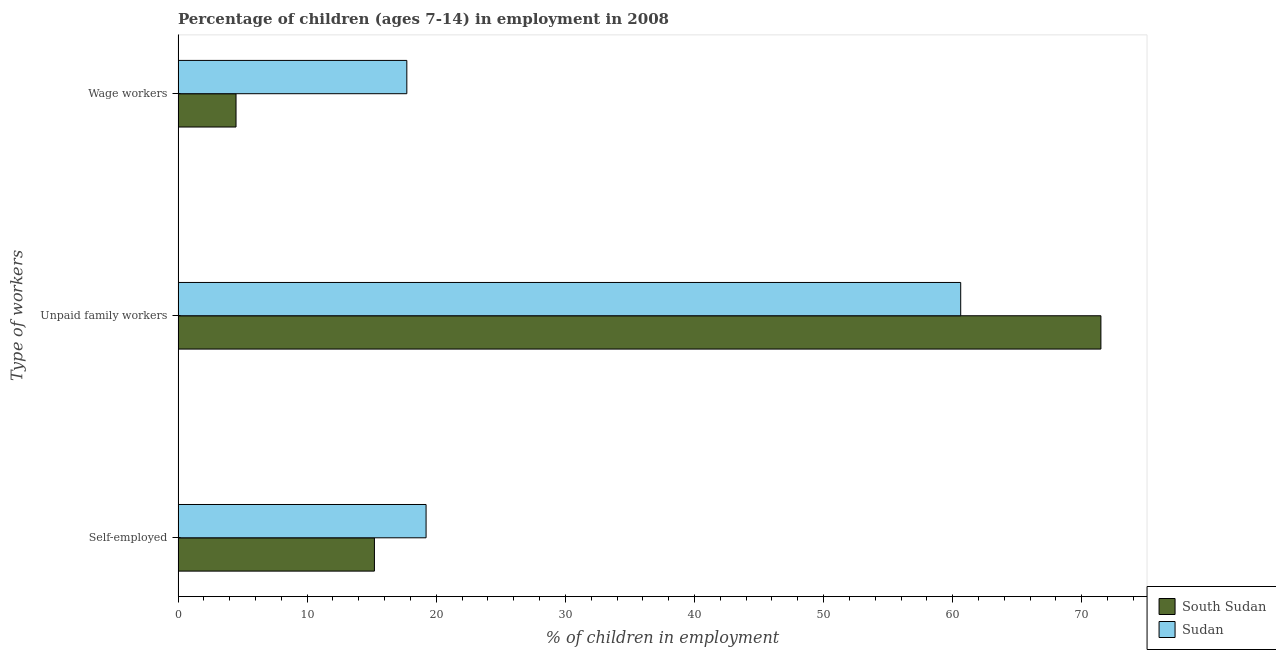How many groups of bars are there?
Keep it short and to the point. 3. Are the number of bars per tick equal to the number of legend labels?
Ensure brevity in your answer.  Yes. How many bars are there on the 3rd tick from the top?
Give a very brief answer. 2. What is the label of the 3rd group of bars from the top?
Your answer should be compact. Self-employed. What is the percentage of self employed children in Sudan?
Your response must be concise. 19.21. Across all countries, what is the maximum percentage of children employed as wage workers?
Ensure brevity in your answer.  17.72. Across all countries, what is the minimum percentage of children employed as wage workers?
Your answer should be very brief. 4.49. In which country was the percentage of children employed as unpaid family workers maximum?
Make the answer very short. South Sudan. In which country was the percentage of children employed as wage workers minimum?
Make the answer very short. South Sudan. What is the total percentage of children employed as wage workers in the graph?
Provide a succinct answer. 22.21. What is the difference between the percentage of children employed as unpaid family workers in South Sudan and that in Sudan?
Make the answer very short. 10.86. What is the difference between the percentage of children employed as unpaid family workers in South Sudan and the percentage of self employed children in Sudan?
Keep it short and to the point. 52.27. What is the average percentage of children employed as unpaid family workers per country?
Provide a short and direct response. 66.05. What is the difference between the percentage of children employed as wage workers and percentage of children employed as unpaid family workers in South Sudan?
Your response must be concise. -66.99. What is the ratio of the percentage of self employed children in South Sudan to that in Sudan?
Make the answer very short. 0.79. Is the percentage of children employed as wage workers in Sudan less than that in South Sudan?
Make the answer very short. No. Is the difference between the percentage of self employed children in South Sudan and Sudan greater than the difference between the percentage of children employed as unpaid family workers in South Sudan and Sudan?
Give a very brief answer. No. What is the difference between the highest and the second highest percentage of children employed as wage workers?
Ensure brevity in your answer.  13.23. In how many countries, is the percentage of children employed as unpaid family workers greater than the average percentage of children employed as unpaid family workers taken over all countries?
Your answer should be very brief. 1. What does the 2nd bar from the top in Self-employed represents?
Give a very brief answer. South Sudan. What does the 2nd bar from the bottom in Self-employed represents?
Give a very brief answer. Sudan. What is the difference between two consecutive major ticks on the X-axis?
Offer a terse response. 10. Are the values on the major ticks of X-axis written in scientific E-notation?
Provide a short and direct response. No. Where does the legend appear in the graph?
Ensure brevity in your answer.  Bottom right. How many legend labels are there?
Provide a short and direct response. 2. How are the legend labels stacked?
Your response must be concise. Vertical. What is the title of the graph?
Make the answer very short. Percentage of children (ages 7-14) in employment in 2008. Does "Switzerland" appear as one of the legend labels in the graph?
Your answer should be very brief. No. What is the label or title of the X-axis?
Give a very brief answer. % of children in employment. What is the label or title of the Y-axis?
Your response must be concise. Type of workers. What is the % of children in employment in South Sudan in Self-employed?
Your answer should be compact. 15.21. What is the % of children in employment in Sudan in Self-employed?
Offer a very short reply. 19.21. What is the % of children in employment in South Sudan in Unpaid family workers?
Make the answer very short. 71.48. What is the % of children in employment of Sudan in Unpaid family workers?
Keep it short and to the point. 60.62. What is the % of children in employment of South Sudan in Wage workers?
Offer a terse response. 4.49. What is the % of children in employment in Sudan in Wage workers?
Give a very brief answer. 17.72. Across all Type of workers, what is the maximum % of children in employment in South Sudan?
Provide a short and direct response. 71.48. Across all Type of workers, what is the maximum % of children in employment in Sudan?
Ensure brevity in your answer.  60.62. Across all Type of workers, what is the minimum % of children in employment of South Sudan?
Your answer should be very brief. 4.49. Across all Type of workers, what is the minimum % of children in employment in Sudan?
Keep it short and to the point. 17.72. What is the total % of children in employment of South Sudan in the graph?
Provide a short and direct response. 91.18. What is the total % of children in employment in Sudan in the graph?
Make the answer very short. 97.55. What is the difference between the % of children in employment in South Sudan in Self-employed and that in Unpaid family workers?
Offer a very short reply. -56.27. What is the difference between the % of children in employment of Sudan in Self-employed and that in Unpaid family workers?
Provide a succinct answer. -41.41. What is the difference between the % of children in employment of South Sudan in Self-employed and that in Wage workers?
Offer a terse response. 10.72. What is the difference between the % of children in employment in Sudan in Self-employed and that in Wage workers?
Your answer should be very brief. 1.49. What is the difference between the % of children in employment in South Sudan in Unpaid family workers and that in Wage workers?
Make the answer very short. 66.99. What is the difference between the % of children in employment of Sudan in Unpaid family workers and that in Wage workers?
Your answer should be very brief. 42.9. What is the difference between the % of children in employment of South Sudan in Self-employed and the % of children in employment of Sudan in Unpaid family workers?
Keep it short and to the point. -45.41. What is the difference between the % of children in employment of South Sudan in Self-employed and the % of children in employment of Sudan in Wage workers?
Offer a terse response. -2.51. What is the difference between the % of children in employment in South Sudan in Unpaid family workers and the % of children in employment in Sudan in Wage workers?
Your answer should be compact. 53.76. What is the average % of children in employment of South Sudan per Type of workers?
Give a very brief answer. 30.39. What is the average % of children in employment of Sudan per Type of workers?
Provide a succinct answer. 32.52. What is the difference between the % of children in employment of South Sudan and % of children in employment of Sudan in Self-employed?
Ensure brevity in your answer.  -4. What is the difference between the % of children in employment in South Sudan and % of children in employment in Sudan in Unpaid family workers?
Provide a succinct answer. 10.86. What is the difference between the % of children in employment in South Sudan and % of children in employment in Sudan in Wage workers?
Your answer should be compact. -13.23. What is the ratio of the % of children in employment of South Sudan in Self-employed to that in Unpaid family workers?
Provide a succinct answer. 0.21. What is the ratio of the % of children in employment of Sudan in Self-employed to that in Unpaid family workers?
Offer a very short reply. 0.32. What is the ratio of the % of children in employment of South Sudan in Self-employed to that in Wage workers?
Your answer should be compact. 3.39. What is the ratio of the % of children in employment in Sudan in Self-employed to that in Wage workers?
Provide a succinct answer. 1.08. What is the ratio of the % of children in employment in South Sudan in Unpaid family workers to that in Wage workers?
Offer a very short reply. 15.92. What is the ratio of the % of children in employment in Sudan in Unpaid family workers to that in Wage workers?
Provide a succinct answer. 3.42. What is the difference between the highest and the second highest % of children in employment of South Sudan?
Offer a terse response. 56.27. What is the difference between the highest and the second highest % of children in employment of Sudan?
Make the answer very short. 41.41. What is the difference between the highest and the lowest % of children in employment of South Sudan?
Make the answer very short. 66.99. What is the difference between the highest and the lowest % of children in employment in Sudan?
Keep it short and to the point. 42.9. 